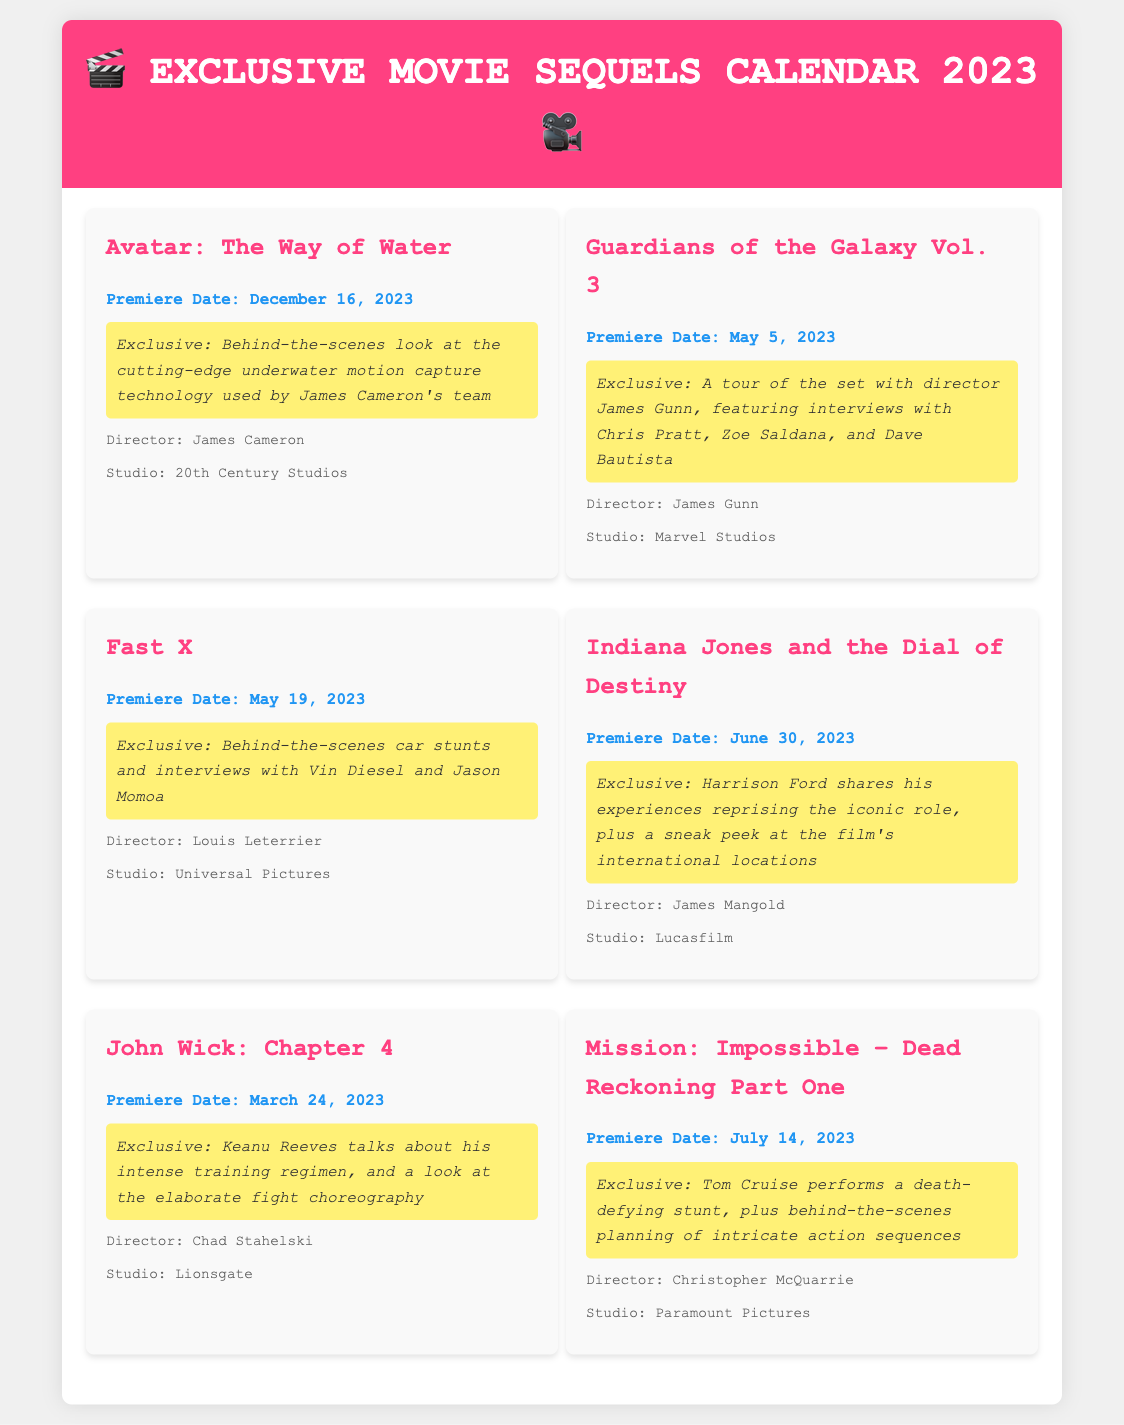What is the premiere date of "Avatar: The Way of Water"? The premiere date listed for "Avatar: The Way of Water" in the document is December 16, 2023.
Answer: December 16, 2023 Who directed "Guardians of the Galaxy Vol. 3"? The document states that "Guardians of the Galaxy Vol. 3" was directed by James Gunn.
Answer: James Gunn What exclusive content is featured for "Fast X"? The document describes the exclusive content for "Fast X" as behind-the-scenes car stunts and interviews with Vin Diesel and Jason Momoa.
Answer: Behind-the-scenes car stunts and interviews What studio produced "Indiana Jones and the Dial of Destiny"? According to the document, "Indiana Jones and the Dial of Destiny" was produced by Lucasfilm.
Answer: Lucasfilm How many movies are listed in the calendar? The document provides a total of six movies in the calendar.
Answer: Six What is the release date of "Mission: Impossible – Dead Reckoning Part One"? The release date mentioned for "Mission: Impossible – Dead Reckoning Part One" is July 14, 2023.
Answer: July 14, 2023 What type of exclusive footage is provided for "John Wick: Chapter 4"? The exclusive footage for "John Wick: Chapter 4" includes Keanu Reeves talking about his training regimen and a look at the fight choreography.
Answer: Training regimen and fight choreography Which movie features a sneak peek at international locations? The document mentions that "Indiana Jones and the Dial of Destiny" features a sneak peek at the film's international locations.
Answer: Indiana Jones and the Dial of Destiny 